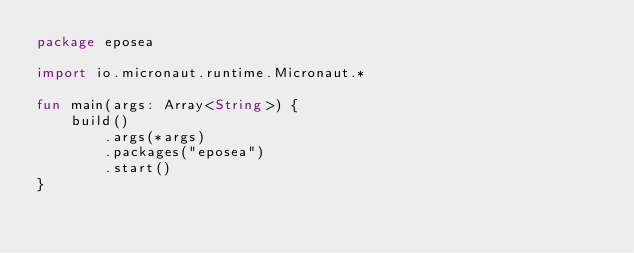Convert code to text. <code><loc_0><loc_0><loc_500><loc_500><_Kotlin_>package eposea

import io.micronaut.runtime.Micronaut.*

fun main(args: Array<String>) {
    build()
        .args(*args)
        .packages("eposea")
        .start()
}
</code> 